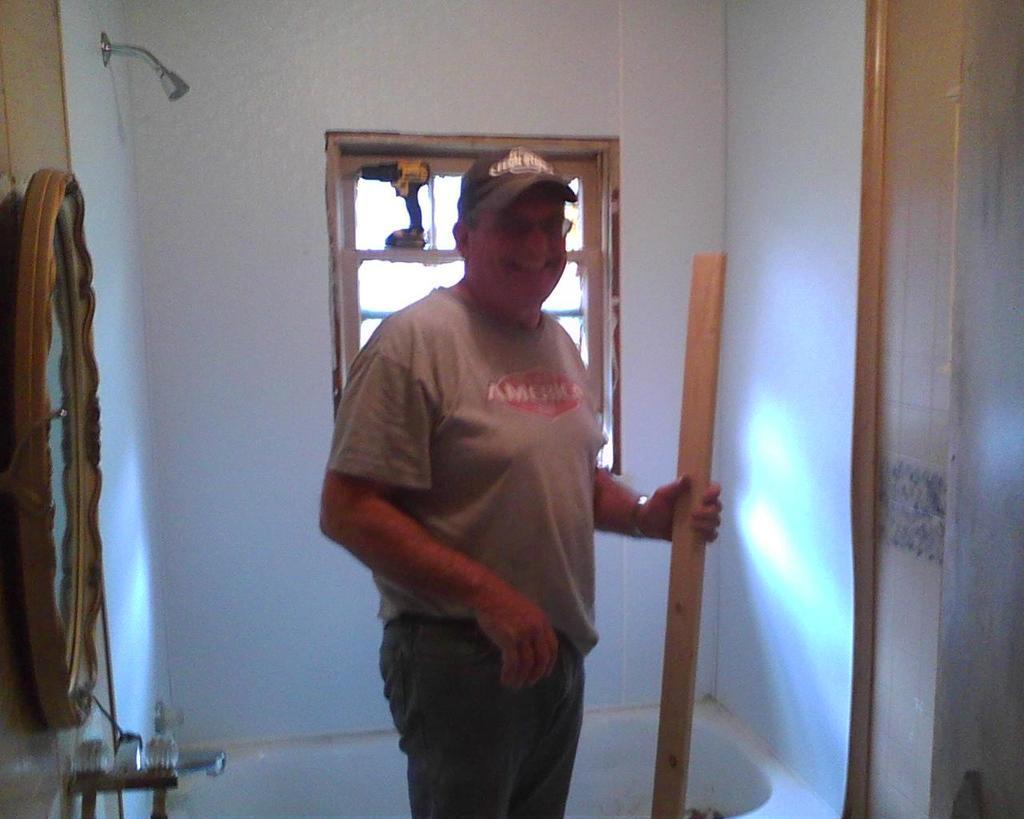In one or two sentences, can you explain what this image depicts? In the image there is a man with spectacles and there is a cap on the head. And he is holding a wooden object in the hand. On the left corner of the image there is a wall with a mirror and a tap and also there is an overhead shower. Behind the man there is a bathtub. And also there is a wall with window. On the right side of the image there is a wall. 